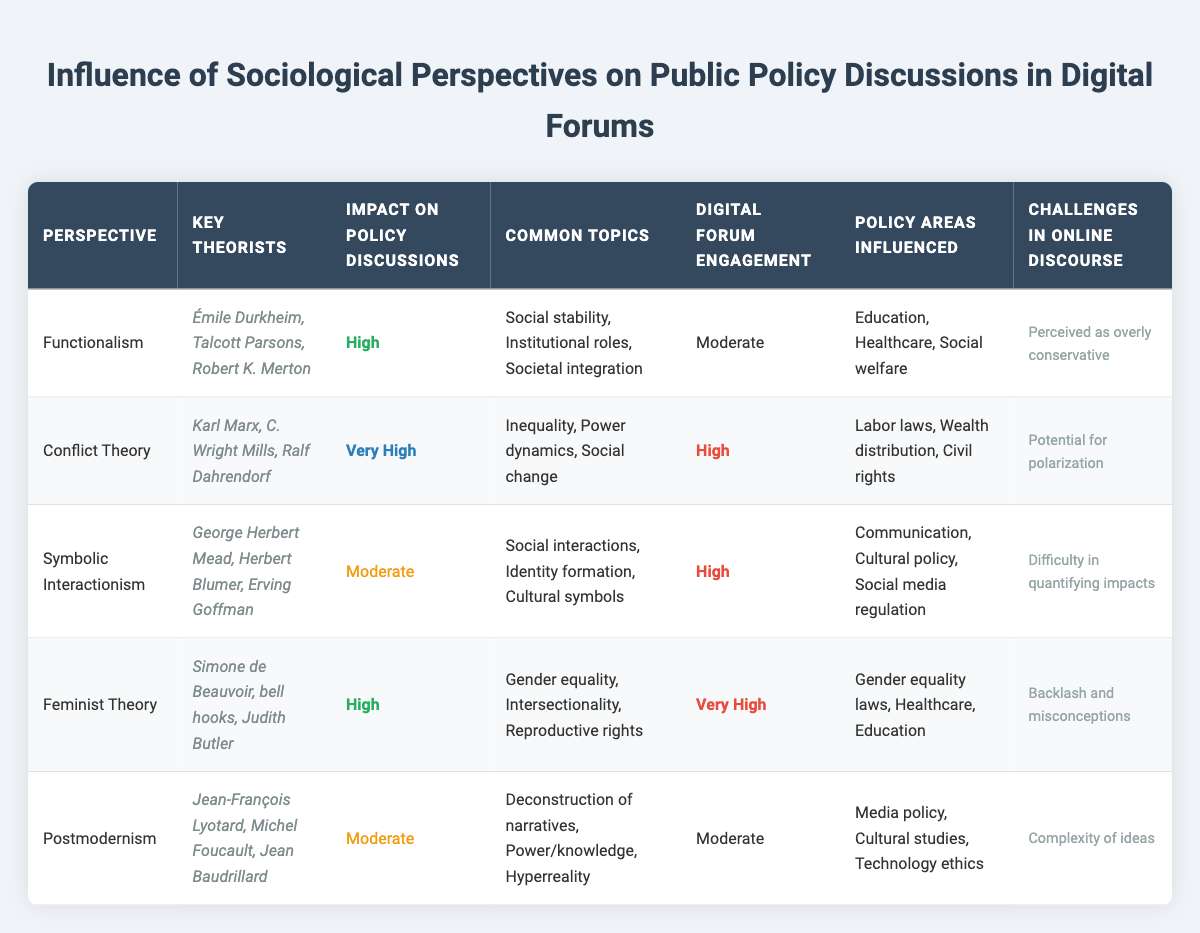What is the impact on policy discussions of Conflict Theory? The table shows that the impact on policy discussions for Conflict Theory is categorized as "Very High." This information can be found directly in the table under the "Impact on Policy Discussions" column corresponding to Conflict Theory.
Answer: Very High Which perspective has a moderate level of digital forum engagement? By examining the "Digital Forum Engagement" column, we can see that both Functionalism and Postmodernism have "Moderate" engagement levels. This indicates that they are not as actively discussed in digital forums compared to others.
Answer: Functionalism and Postmodernism What percentage of perspectives have a high impact on policy discussions? There are 5 perspectives in total shown in the table. Out of these, 2 (Functionalism and Feminist Theory) have "High" as their impact level. To find the percentage, we take (2/5) * 100 = 40%.
Answer: 40% Is Feminist Theory associated with high digital forum engagement? Looking at the "Digital Forum Engagement" column, Feminist Theory has a status of "Very High." This indicates strong active engagement in digital forums.
Answer: Yes Which perspective has the least influence on policy areas? From the policy areas influenced, Postmodernism has the least specificity with only three more general fields listed (Media policy, Cultural studies, Technology ethics) compared to others that mention specific laws or regulations.
Answer: Postmodernism How many policy areas influenced are associated with Conflict Theory? The table lists three specific policy areas influenced by Conflict Theory: Labor laws, Wealth distribution, and Civil rights. Thus, we can count these entries directly from the corresponding row.
Answer: 3 What are the common topics discussed under Symbolic Interactionism? By looking at the "Common Topics" column for Symbolic Interactionism, we can see it mentions three key areas: Social interactions, Identity formation, and Cultural symbols. Collectively, these areas illustrate the core discussions around this sociological perspective.
Answer: Social interactions, Identity formation, Cultural symbols What challenges are identified for Functionalism and Postmodernism in online discourse? From the "Challenges in Online Discourse" column, Functionalism is noted to face challenges of being "Perceived as overly conservative" whereas Postmodernism deals with the "Complexity of ideas." This requires looking at each respective entry directly.
Answer: Functionalism: Perceived as overly conservative; Postmodernism: Complexity of ideas Which perspective has the highest digital forum engagement among the listed sociological perspectives? Reviewing the "Digital Forum Engagement" column, Feminist Theory has "Very High" engagement, which is the highest level indicated in the table. This directly compares to the engagement levels of the other perspectives.
Answer: Feminist Theory 